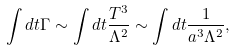Convert formula to latex. <formula><loc_0><loc_0><loc_500><loc_500>\int d t \Gamma \sim \int d t \frac { T ^ { 3 } } { \Lambda ^ { 2 } } \sim \int d t \frac { 1 } { a ^ { 3 } \Lambda ^ { 2 } } ,</formula> 